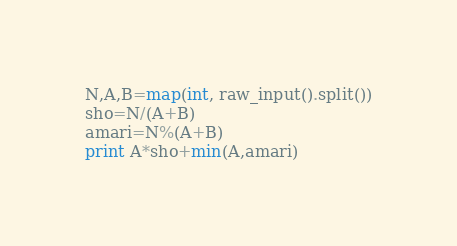<code> <loc_0><loc_0><loc_500><loc_500><_Python_>N,A,B=map(int, raw_input().split())
sho=N/(A+B)
amari=N%(A+B)
print A*sho+min(A,amari)</code> 